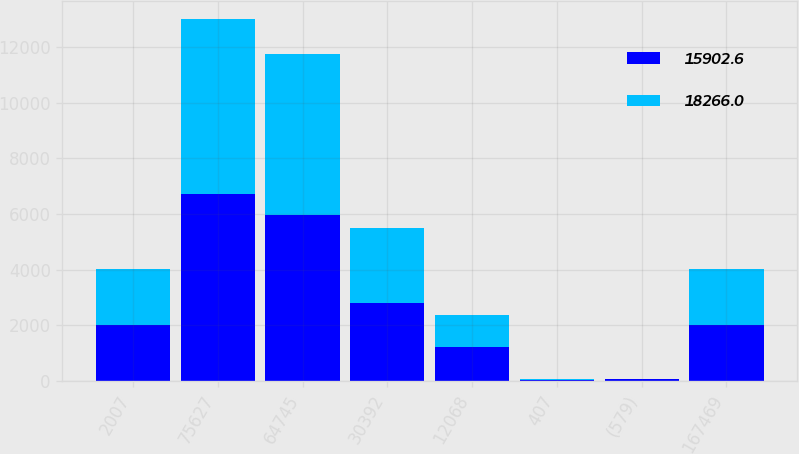Convert chart. <chart><loc_0><loc_0><loc_500><loc_500><stacked_bar_chart><ecel><fcel>2007<fcel>75627<fcel>64745<fcel>30392<fcel>12068<fcel>407<fcel>(579)<fcel>167469<nl><fcel>15902.6<fcel>2006<fcel>6740.9<fcel>5982<fcel>2813.1<fcel>1237.4<fcel>32.3<fcel>58.8<fcel>2005.5<nl><fcel>18266<fcel>2005<fcel>6287.4<fcel>5781.3<fcel>2672.2<fcel>1149.6<fcel>31.4<fcel>19.3<fcel>2005.5<nl></chart> 